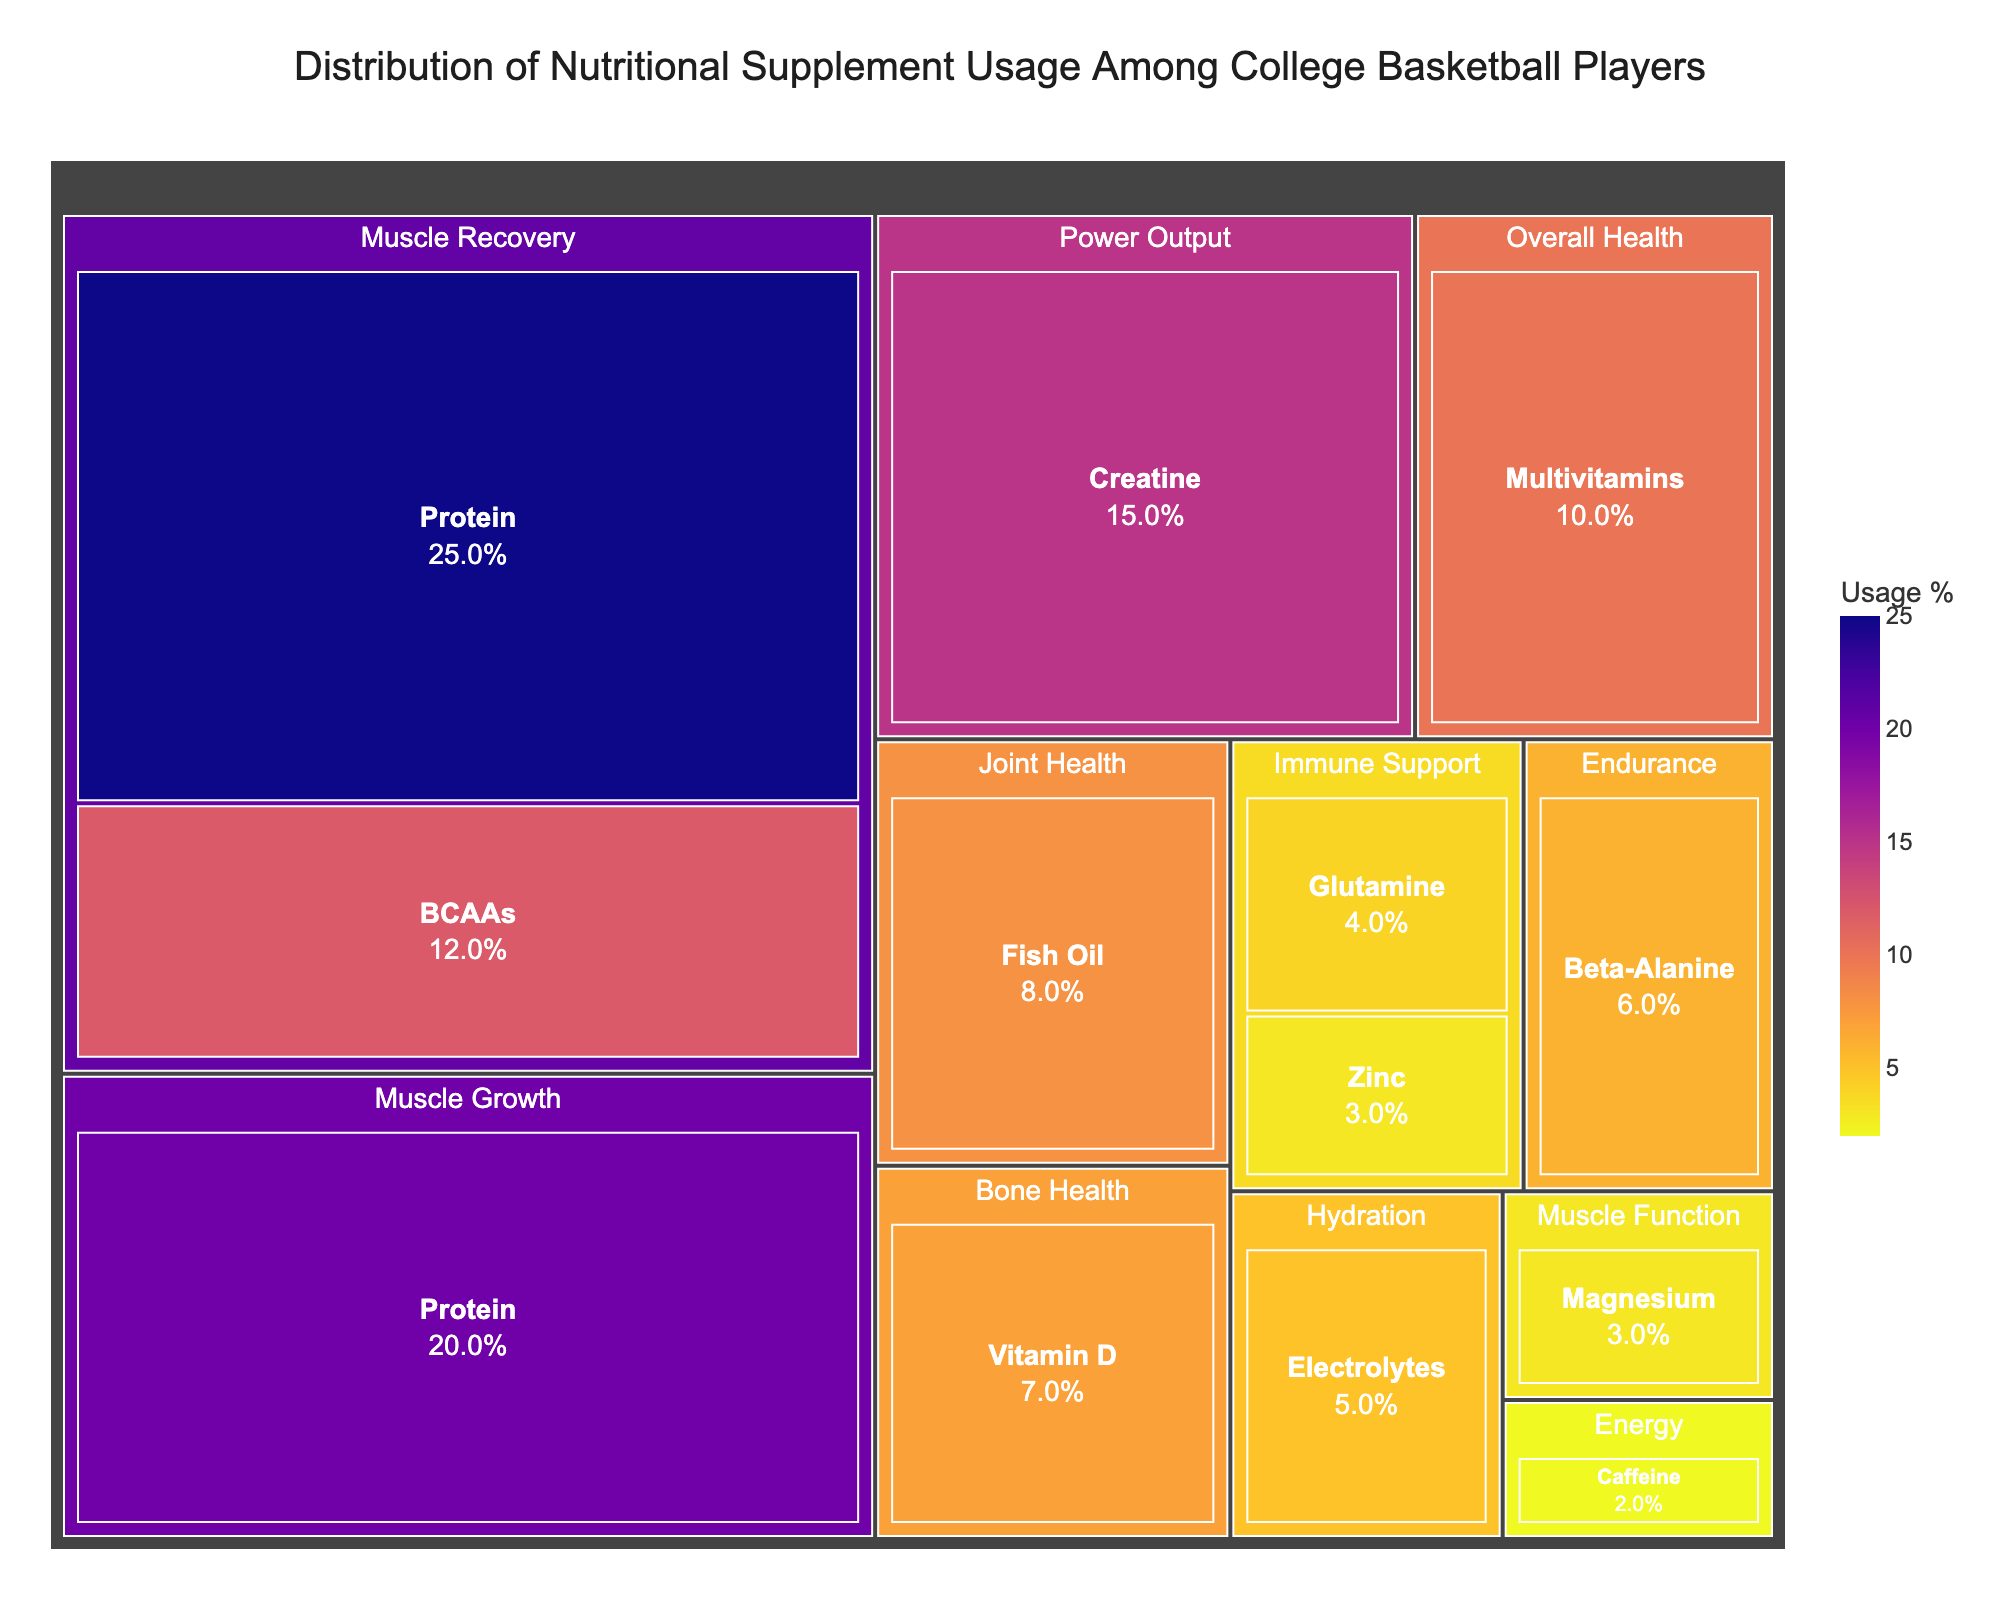What is the title of the figure? The title of the figure is located at the top and provides a brief overview of the displayed data.
Answer: Distribution of Nutritional Supplement Usage Among College Basketball Players Which intended benefit category has the highest usage percentage? You can observe the size of the tiles associated with each intended benefit. The largest tile by usage percentage belongs to Muscle Recovery.
Answer: Muscle Recovery What is the combined usage percentage of Protein supplements for Muscle Recovery and Muscle Growth? Locate the tiles for Protein under Muscle Recovery (25%) and Muscle Growth (20%), then add these percentages together. 25% + 20% = 45%.
Answer: 45% How does the usage of Multivitamins for Overall Health compare to Fish Oil for Joint Health? Compare the tiles for Multivitamins (10%) and Fish Oil (8%), then determine which is larger. Multivitamins usage is greater.
Answer: Multivitamins usage is greater Which supplement type is used for both Immune Support and Muscle Function? Identify the supplement types associated with each intended benefit. Glutamine and Zinc appear under Immune Support, and Magnesium is under Muscle Function. The question should compare Glutamine (4%), Zinc (3%), and Magnesium (3%). Glutamine and Zinc are for Immune Support, and Magnesium is separate for Muscle Function. Glutamine and Zinc are relevant for Immune support, and Magnesium is distinct for Muscle function.
Answer: Glutamine and Zinc for Immune support, Magnesium for Muscle function What percentage of players uses supplements for Hydration? Look for the tile labeled Hydration and note the Usage Percentage displayed.
Answer: 5% Rank the top three supplements by usage percentage. Identify the top three tiles with the highest usage percentages: Protein (Muscle Recovery) at 25%, Protein (Muscle Growth) at 20%, and Creatine (Power Output) at 15%.
Answer: Protein (Muscle Recovery), Protein (Muscle Growth), Creatine What is the least used supplement type, and for what intended benefit? Determine the smallest tile by usage percentage. Caffeine has the smallest percentage at 2%, used for Energy.
Answer: Caffeine, Energy What is the total usage percentage for supplements intended for Immune Support? Sum the usage percentages of Glutamine (4%) and Zinc (3%). 4% + 3% = 7%.
Answer: 7% Which intended benefit category includes the most diverse range of supplement types? Observe which category has the most different supplement types listed under it. Muscle Recovery and Immune Support each include supplements like Protein, BCAAs, Glutamine, and Zinc. Muscle Recovery has two distinct supplement types, but Immune Support encompasses two different types (Glutamine and Zinc).
Answer: Muscle Recovery and Immune Support 